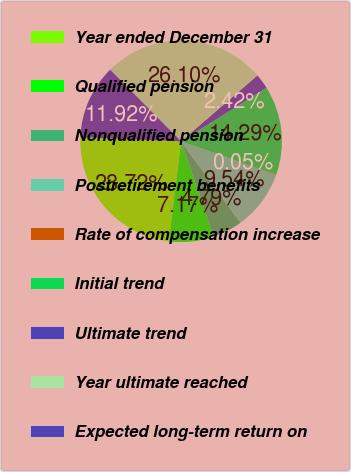<chart> <loc_0><loc_0><loc_500><loc_500><pie_chart><fcel>Year ended December 31<fcel>Qualified pension<fcel>Nonqualified pension<fcel>Postretirement benefits<fcel>Rate of compensation increase<fcel>Initial trend<fcel>Ultimate trend<fcel>Year ultimate reached<fcel>Expected long-term return on<nl><fcel>23.72%<fcel>7.17%<fcel>4.79%<fcel>9.54%<fcel>0.05%<fcel>14.29%<fcel>2.42%<fcel>26.1%<fcel>11.92%<nl></chart> 